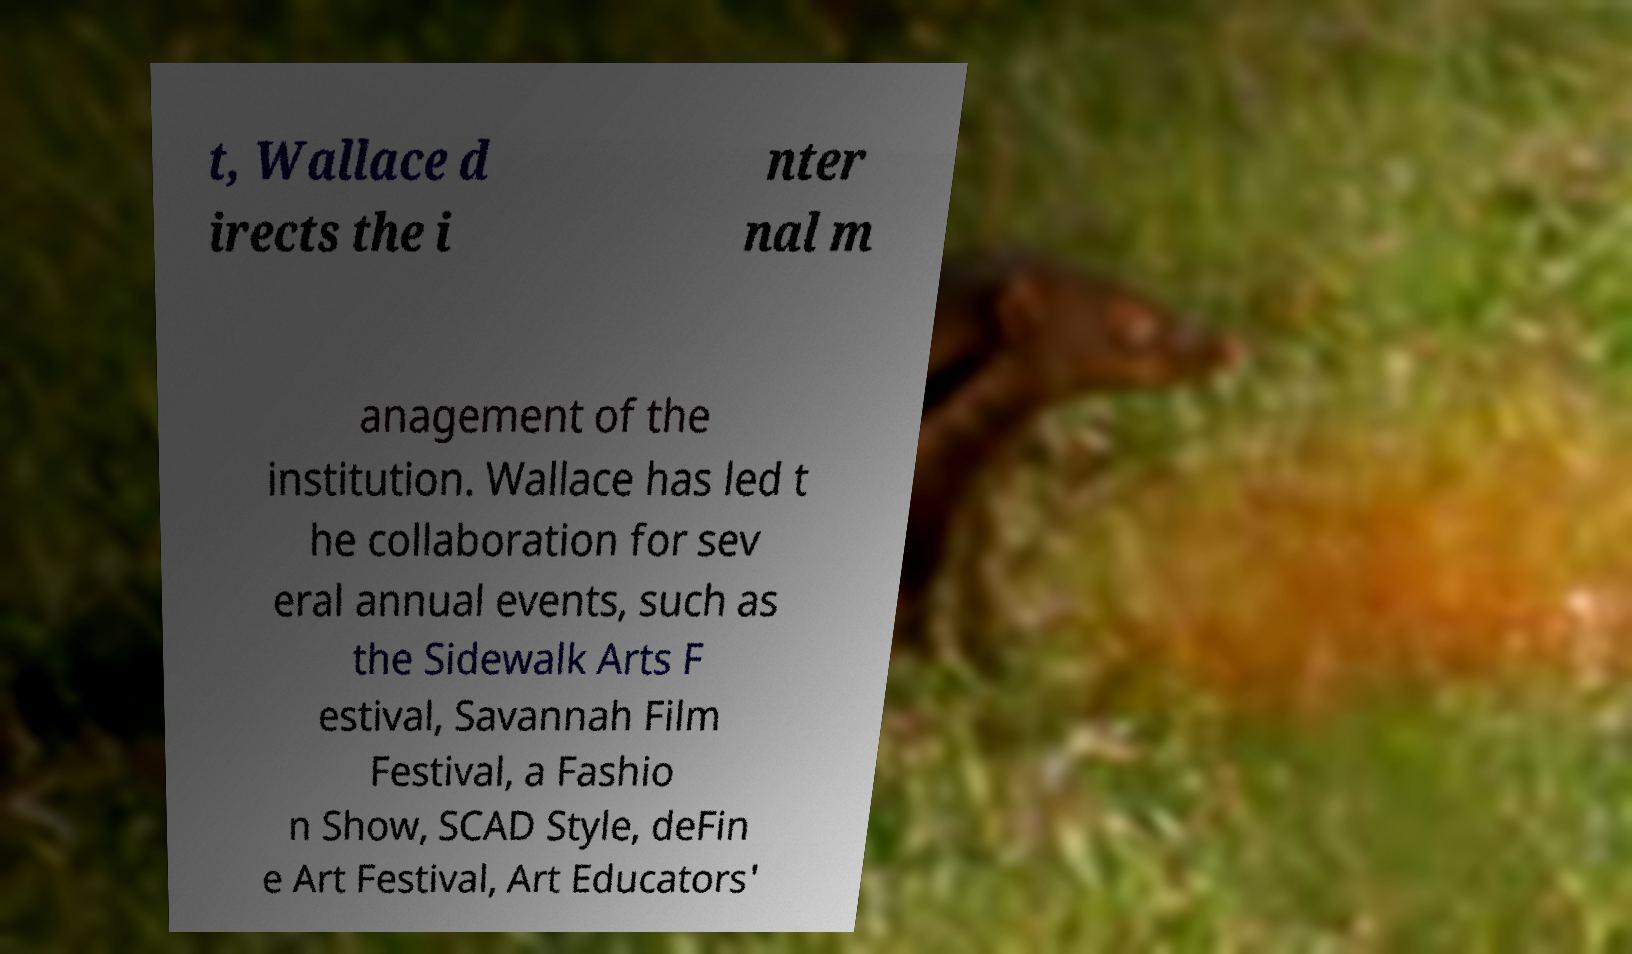Can you read and provide the text displayed in the image?This photo seems to have some interesting text. Can you extract and type it out for me? t, Wallace d irects the i nter nal m anagement of the institution. Wallace has led t he collaboration for sev eral annual events, such as the Sidewalk Arts F estival, Savannah Film Festival, a Fashio n Show, SCAD Style, deFin e Art Festival, Art Educators' 